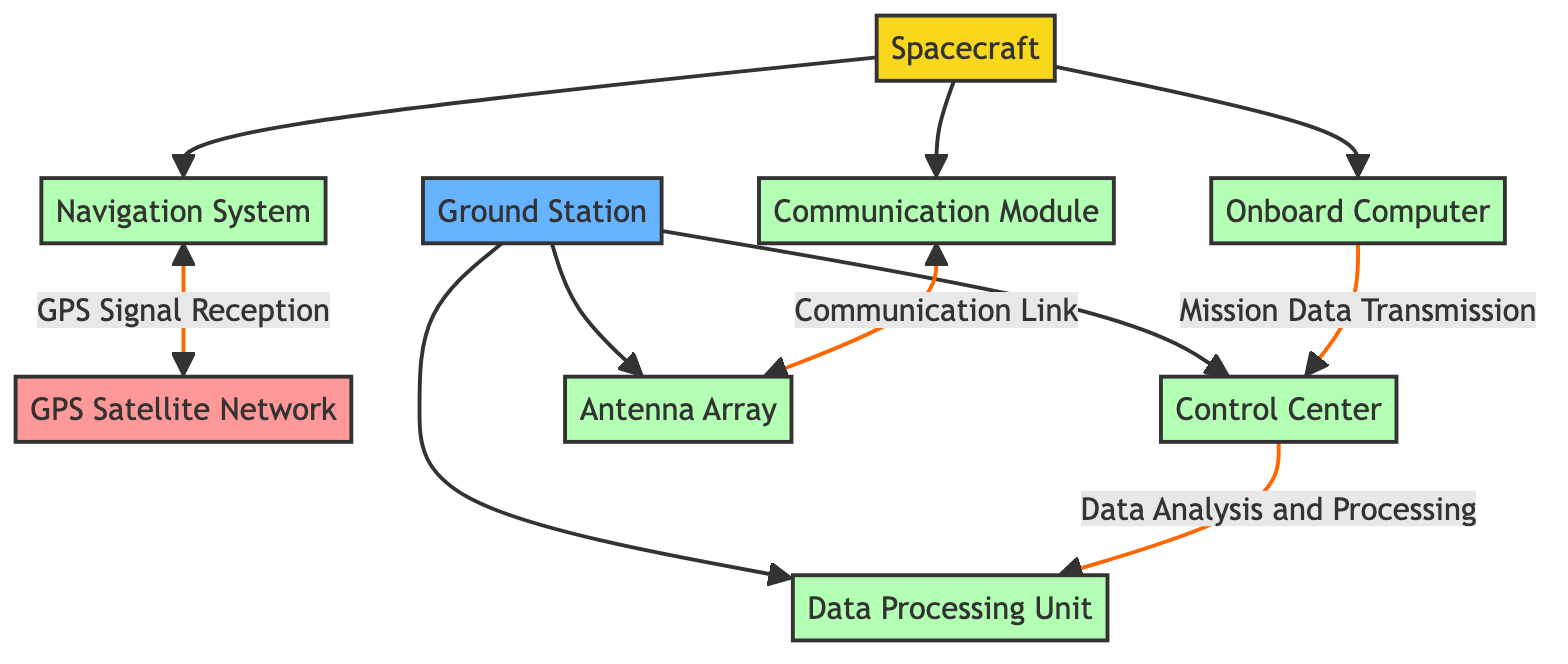What is the type of the node representing the spacecraft? The node representing the spacecraft is categorized as a "Vehicle" type.
Answer: Vehicle How many subcomponents does the Ground Station node have? The Ground Station node contains three subcomponents: Control Center, Antenna Array, and Data Processing Unit.
Answer: Three What type of data link exists between the Navigation System and the GPS Satellite Network? The link type between the Navigation System and the GPS Satellite Network is described as "Data."
Answer: Data Which subsystem is responsible for data analysis and processing? The Data Processing Unit is identified as the subsystem responsible for data analysis and processing.
Answer: Data Processing Unit What is the relationship between the Communication Module and the Antenna Array? The relationship is a bidirectional communication link described as "Communication Link."
Answer: Communication Link How many total nodes are present in this diagram? The total number of nodes includes the Spacecraft, Ground Station, GPS Satellite Network, and their respective subcomponents, totaling eight nodes.
Answer: Eight Which subsystem sends mission data to the Control Center? The Onboard Computer subsystem is designated to send mission data to the Control Center.
Answer: Onboard Computer What type of facility is the Ground Station classified as? The Ground Station is classified as a "Facility" within the diagram.
Answer: Facility Which component receives positioning data from the GPS Satellite Network? The Navigation System within the Spacecraft receives positioning data from the GPS Satellite Network.
Answer: Navigation System 